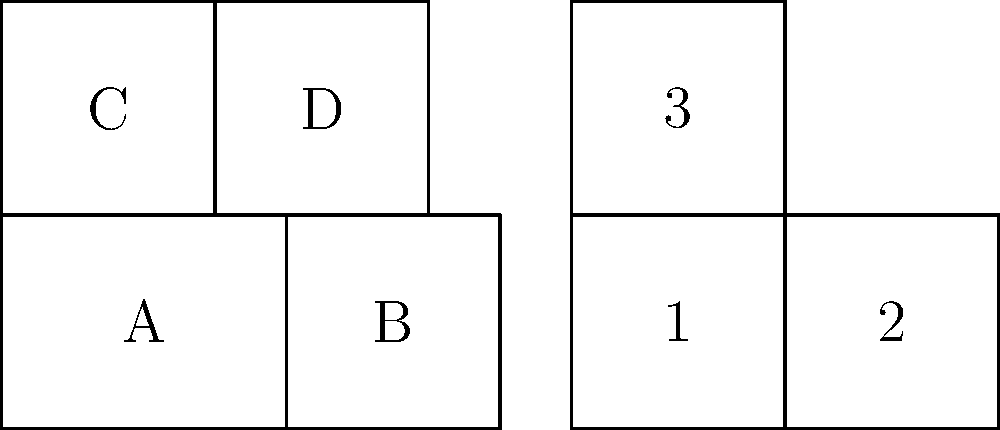As an occupational therapist integrating traditional methods with technology, you're designing a foldable therapeutic exercise mat. The unfolded mat is shown on the left, and the correctly folded mat is on the right. Which section of the unfolded mat corresponds to section 2 of the folded mat? To solve this problem, we need to mentally fold the mat and track the movement of each section:

1. First, observe that the folded mat has three visible sections (1, 2, and 3), while the unfolded mat has four sections (A, B, C, and D).

2. Section 1 of the folded mat is clearly the bottom-left section, which corresponds to section A of the unfolded mat.

3. Section 3 of the folded mat is the top section, which corresponds to section C of the unfolded mat.

4. The remaining section 2 of the folded mat must correspond to one of the two right sections (B or D) of the unfolded mat.

5. To determine which one it is, we need to consider the folding process:
   - The right side of the unfolded mat (sections B and D) will fold over onto the left side.
   - When folded, section D will be on top of section C, hidden from view.
   - Section B will become visible on the right side of the folded mat.

6. Therefore, section 2 of the folded mat corresponds to section B of the unfolded mat.

This spatial reasoning process is crucial for occupational therapists when designing and using adaptive equipment or therapeutic tools that may require assembly or folding.
Answer: B 